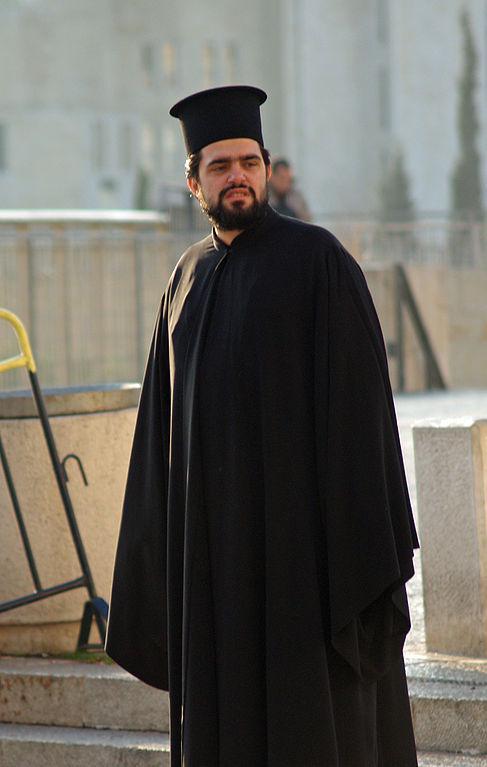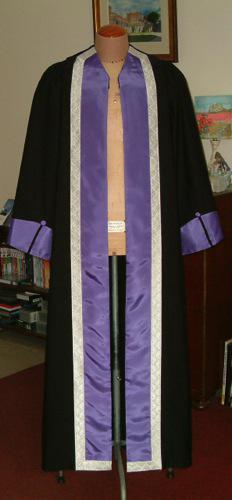The first image is the image on the left, the second image is the image on the right. Given the left and right images, does the statement "There are exactly three graduation robes, two in one image and one in the other, one or more robes does not contain people." hold true? Answer yes or no. No. 